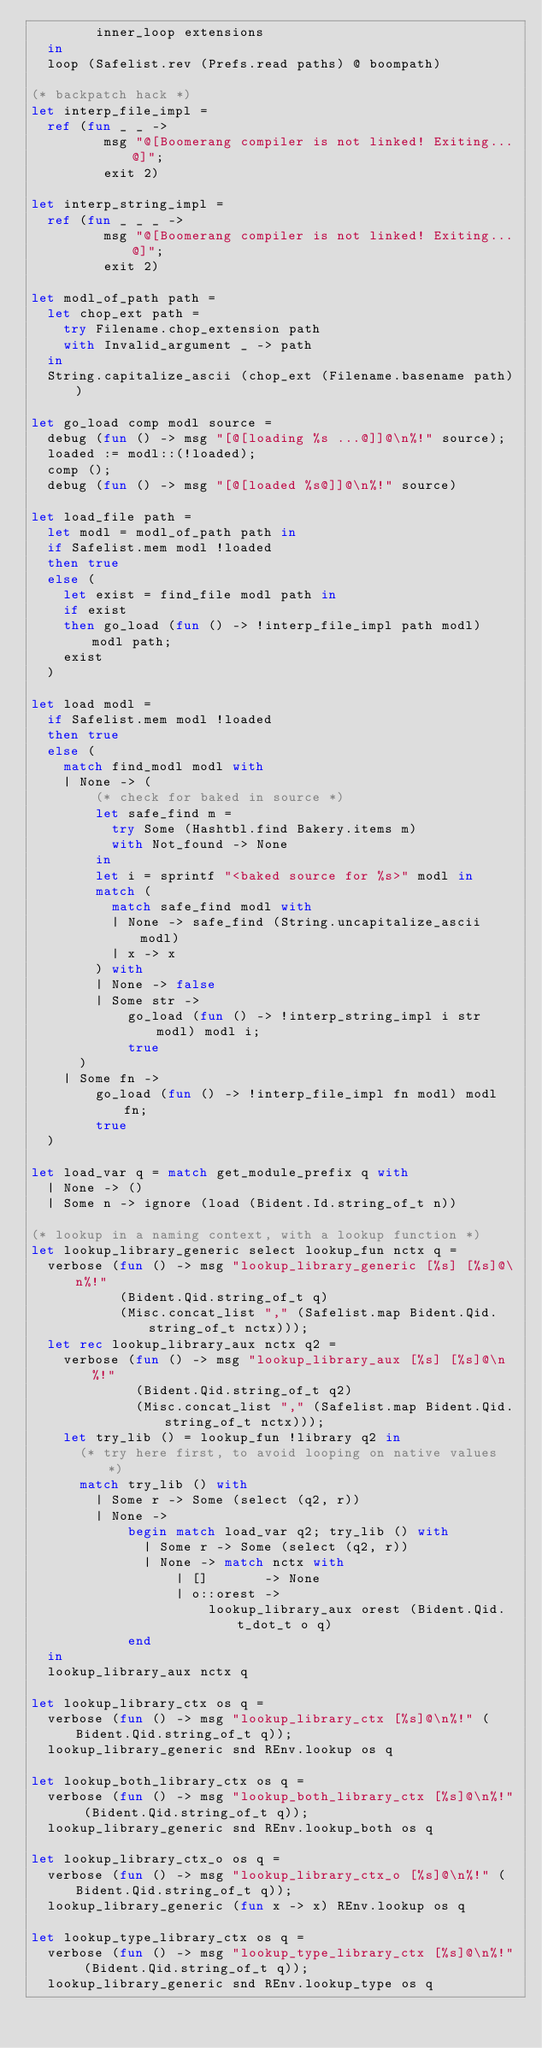Convert code to text. <code><loc_0><loc_0><loc_500><loc_500><_OCaml_>        inner_loop extensions
  in
  loop (Safelist.rev (Prefs.read paths) @ boompath)

(* backpatch hack *)
let interp_file_impl = 
  ref (fun _ _ -> 
         msg "@[Boomerang compiler is not linked! Exiting...@]"; 
         exit 2)

let interp_string_impl = 
  ref (fun _ _ _ -> 
         msg "@[Boomerang compiler is not linked! Exiting...@]"; 
         exit 2)  

let modl_of_path path =
  let chop_ext path =
    try Filename.chop_extension path
    with Invalid_argument _ -> path
  in
  String.capitalize_ascii (chop_ext (Filename.basename path))
  
let go_load comp modl source =
  debug (fun () -> msg "[@[loading %s ...@]]@\n%!" source);
  loaded := modl::(!loaded);
  comp ();
  debug (fun () -> msg "[@[loaded %s@]]@\n%!" source)

let load_file path =
  let modl = modl_of_path path in
  if Safelist.mem modl !loaded
  then true
  else (
    let exist = find_file modl path in
    if exist
    then go_load (fun () -> !interp_file_impl path modl) modl path;
    exist
  )

let load modl =
  if Safelist.mem modl !loaded
  then true
  else (
    match find_modl modl with 
    | None -> (
        (* check for baked in source *)
        let safe_find m =
          try Some (Hashtbl.find Bakery.items m)
          with Not_found -> None
        in
        let i = sprintf "<baked source for %s>" modl in  
        match (
          match safe_find modl with
          | None -> safe_find (String.uncapitalize_ascii modl)
          | x -> x
        ) with
        | None -> false
        | Some str ->
            go_load (fun () -> !interp_string_impl i str modl) modl i;
            true
      )
    | Some fn ->
        go_load (fun () -> !interp_file_impl fn modl) modl fn;
        true
  )
      
let load_var q = match get_module_prefix q with 
  | None -> ()
  | Some n -> ignore (load (Bident.Id.string_of_t n))

(* lookup in a naming context, with a lookup function *)
let lookup_library_generic select lookup_fun nctx q = 
  verbose (fun () -> msg "lookup_library_generic [%s] [%s]@\n%!" 
           (Bident.Qid.string_of_t q)
           (Misc.concat_list "," (Safelist.map Bident.Qid.string_of_t nctx)));
  let rec lookup_library_aux nctx q2 =       
    verbose (fun () -> msg "lookup_library_aux [%s] [%s]@\n%!" 
             (Bident.Qid.string_of_t q2)
             (Misc.concat_list "," (Safelist.map Bident.Qid.string_of_t nctx)));
    let try_lib () = lookup_fun !library q2 in
      (* try here first, to avoid looping on native values *)
      match try_lib () with
        | Some r -> Some (select (q2, r))
        | None -> 
            begin match load_var q2; try_lib () with
              | Some r -> Some (select (q2, r))
              | None -> match nctx with 
                  | []       -> None
                  | o::orest -> 
                      lookup_library_aux orest (Bident.Qid.t_dot_t o q) 
            end
  in
  lookup_library_aux nctx q

let lookup_library_ctx os q = 
  verbose (fun () -> msg "lookup_library_ctx [%s]@\n%!" (Bident.Qid.string_of_t q));
  lookup_library_generic snd REnv.lookup os q

let lookup_both_library_ctx os q = 
  verbose (fun () -> msg "lookup_both_library_ctx [%s]@\n%!" (Bident.Qid.string_of_t q));
  lookup_library_generic snd REnv.lookup_both os q

let lookup_library_ctx_o os q = 
  verbose (fun () -> msg "lookup_library_ctx_o [%s]@\n%!" (Bident.Qid.string_of_t q));
  lookup_library_generic (fun x -> x) REnv.lookup os q

let lookup_type_library_ctx os q = 
  verbose (fun () -> msg "lookup_type_library_ctx [%s]@\n%!" (Bident.Qid.string_of_t q));
  lookup_library_generic snd REnv.lookup_type os q
</code> 